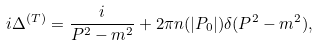<formula> <loc_0><loc_0><loc_500><loc_500>i \Delta ^ { ( T ) } = \frac { i } { P ^ { 2 } - m ^ { 2 } } + 2 \pi n ( | P _ { 0 } | ) \delta ( P ^ { 2 } - m ^ { 2 } ) ,</formula> 